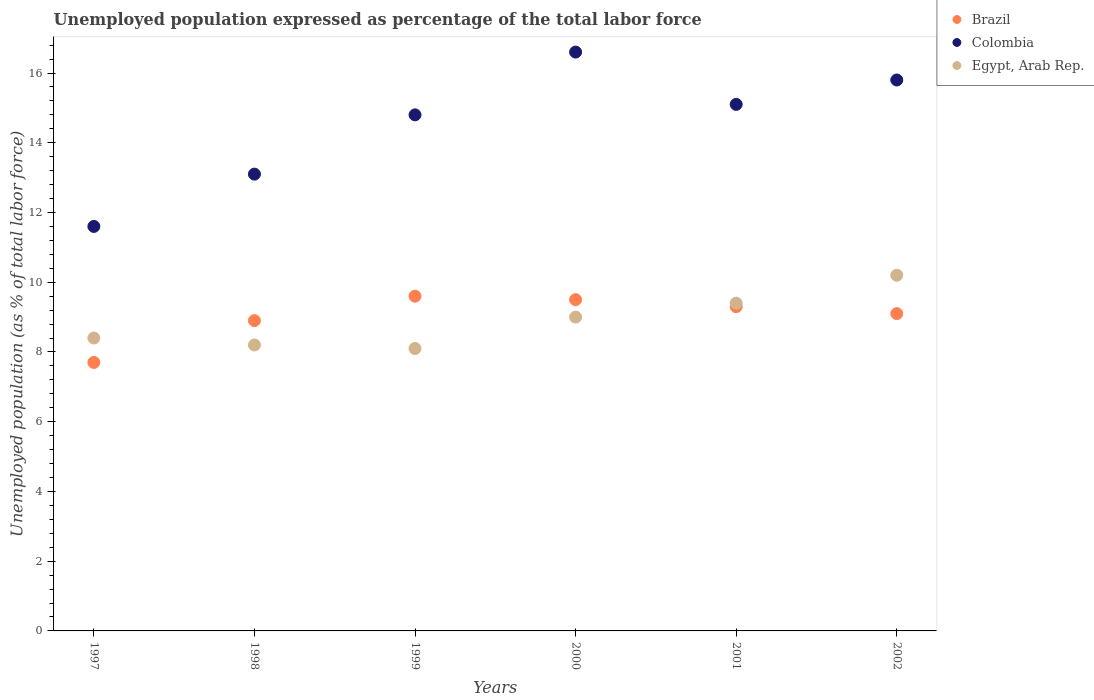How many different coloured dotlines are there?
Provide a succinct answer. 3. What is the unemployment in in Brazil in 1998?
Your answer should be very brief. 8.9. Across all years, what is the maximum unemployment in in Colombia?
Your answer should be compact. 16.6. Across all years, what is the minimum unemployment in in Egypt, Arab Rep.?
Ensure brevity in your answer.  8.1. In which year was the unemployment in in Colombia maximum?
Your answer should be compact. 2000. What is the total unemployment in in Colombia in the graph?
Give a very brief answer. 87. What is the difference between the unemployment in in Brazil in 1997 and that in 2002?
Give a very brief answer. -1.4. What is the difference between the unemployment in in Egypt, Arab Rep. in 1998 and the unemployment in in Colombia in 1999?
Your response must be concise. -6.6. What is the average unemployment in in Colombia per year?
Offer a terse response. 14.5. In the year 2000, what is the difference between the unemployment in in Colombia and unemployment in in Egypt, Arab Rep.?
Give a very brief answer. 7.6. In how many years, is the unemployment in in Egypt, Arab Rep. greater than 9.6 %?
Your answer should be compact. 1. What is the ratio of the unemployment in in Colombia in 1998 to that in 2002?
Ensure brevity in your answer.  0.83. Is the unemployment in in Colombia in 1997 less than that in 1998?
Your answer should be compact. Yes. What is the difference between the highest and the second highest unemployment in in Colombia?
Provide a succinct answer. 0.8. What is the difference between the highest and the lowest unemployment in in Colombia?
Give a very brief answer. 5. Is the sum of the unemployment in in Colombia in 1998 and 1999 greater than the maximum unemployment in in Brazil across all years?
Offer a terse response. Yes. Is it the case that in every year, the sum of the unemployment in in Brazil and unemployment in in Colombia  is greater than the unemployment in in Egypt, Arab Rep.?
Keep it short and to the point. Yes. Does the unemployment in in Egypt, Arab Rep. monotonically increase over the years?
Ensure brevity in your answer.  No. Is the unemployment in in Egypt, Arab Rep. strictly greater than the unemployment in in Brazil over the years?
Make the answer very short. No. How many dotlines are there?
Make the answer very short. 3. How many years are there in the graph?
Give a very brief answer. 6. What is the difference between two consecutive major ticks on the Y-axis?
Provide a succinct answer. 2. Are the values on the major ticks of Y-axis written in scientific E-notation?
Provide a succinct answer. No. Does the graph contain any zero values?
Your response must be concise. No. Does the graph contain grids?
Your answer should be very brief. No. How are the legend labels stacked?
Make the answer very short. Vertical. What is the title of the graph?
Give a very brief answer. Unemployed population expressed as percentage of the total labor force. Does "Faeroe Islands" appear as one of the legend labels in the graph?
Provide a short and direct response. No. What is the label or title of the Y-axis?
Your response must be concise. Unemployed population (as % of total labor force). What is the Unemployed population (as % of total labor force) in Brazil in 1997?
Your answer should be very brief. 7.7. What is the Unemployed population (as % of total labor force) of Colombia in 1997?
Provide a succinct answer. 11.6. What is the Unemployed population (as % of total labor force) in Egypt, Arab Rep. in 1997?
Provide a short and direct response. 8.4. What is the Unemployed population (as % of total labor force) of Brazil in 1998?
Your answer should be very brief. 8.9. What is the Unemployed population (as % of total labor force) in Colombia in 1998?
Make the answer very short. 13.1. What is the Unemployed population (as % of total labor force) of Egypt, Arab Rep. in 1998?
Your answer should be very brief. 8.2. What is the Unemployed population (as % of total labor force) in Brazil in 1999?
Provide a short and direct response. 9.6. What is the Unemployed population (as % of total labor force) in Colombia in 1999?
Your answer should be compact. 14.8. What is the Unemployed population (as % of total labor force) in Egypt, Arab Rep. in 1999?
Your answer should be compact. 8.1. What is the Unemployed population (as % of total labor force) of Brazil in 2000?
Offer a very short reply. 9.5. What is the Unemployed population (as % of total labor force) in Colombia in 2000?
Provide a succinct answer. 16.6. What is the Unemployed population (as % of total labor force) of Brazil in 2001?
Give a very brief answer. 9.3. What is the Unemployed population (as % of total labor force) in Colombia in 2001?
Ensure brevity in your answer.  15.1. What is the Unemployed population (as % of total labor force) of Egypt, Arab Rep. in 2001?
Your answer should be very brief. 9.4. What is the Unemployed population (as % of total labor force) of Brazil in 2002?
Your answer should be very brief. 9.1. What is the Unemployed population (as % of total labor force) in Colombia in 2002?
Offer a terse response. 15.8. What is the Unemployed population (as % of total labor force) of Egypt, Arab Rep. in 2002?
Offer a terse response. 10.2. Across all years, what is the maximum Unemployed population (as % of total labor force) of Brazil?
Ensure brevity in your answer.  9.6. Across all years, what is the maximum Unemployed population (as % of total labor force) of Colombia?
Your response must be concise. 16.6. Across all years, what is the maximum Unemployed population (as % of total labor force) in Egypt, Arab Rep.?
Give a very brief answer. 10.2. Across all years, what is the minimum Unemployed population (as % of total labor force) in Brazil?
Your answer should be very brief. 7.7. Across all years, what is the minimum Unemployed population (as % of total labor force) of Colombia?
Keep it short and to the point. 11.6. Across all years, what is the minimum Unemployed population (as % of total labor force) in Egypt, Arab Rep.?
Make the answer very short. 8.1. What is the total Unemployed population (as % of total labor force) in Brazil in the graph?
Ensure brevity in your answer.  54.1. What is the total Unemployed population (as % of total labor force) in Egypt, Arab Rep. in the graph?
Your response must be concise. 53.3. What is the difference between the Unemployed population (as % of total labor force) in Brazil in 1997 and that in 1998?
Your response must be concise. -1.2. What is the difference between the Unemployed population (as % of total labor force) of Colombia in 1997 and that in 1998?
Provide a short and direct response. -1.5. What is the difference between the Unemployed population (as % of total labor force) in Egypt, Arab Rep. in 1997 and that in 1998?
Provide a succinct answer. 0.2. What is the difference between the Unemployed population (as % of total labor force) of Brazil in 1997 and that in 1999?
Offer a terse response. -1.9. What is the difference between the Unemployed population (as % of total labor force) of Colombia in 1997 and that in 2001?
Your answer should be very brief. -3.5. What is the difference between the Unemployed population (as % of total labor force) of Brazil in 1997 and that in 2002?
Your answer should be very brief. -1.4. What is the difference between the Unemployed population (as % of total labor force) of Colombia in 1997 and that in 2002?
Provide a succinct answer. -4.2. What is the difference between the Unemployed population (as % of total labor force) of Egypt, Arab Rep. in 1997 and that in 2002?
Keep it short and to the point. -1.8. What is the difference between the Unemployed population (as % of total labor force) of Brazil in 1998 and that in 2000?
Your answer should be very brief. -0.6. What is the difference between the Unemployed population (as % of total labor force) in Colombia in 1998 and that in 2000?
Offer a terse response. -3.5. What is the difference between the Unemployed population (as % of total labor force) of Egypt, Arab Rep. in 1998 and that in 2000?
Your answer should be compact. -0.8. What is the difference between the Unemployed population (as % of total labor force) in Egypt, Arab Rep. in 1999 and that in 2000?
Offer a terse response. -0.9. What is the difference between the Unemployed population (as % of total labor force) of Egypt, Arab Rep. in 1999 and that in 2001?
Give a very brief answer. -1.3. What is the difference between the Unemployed population (as % of total labor force) in Brazil in 1999 and that in 2002?
Your answer should be very brief. 0.5. What is the difference between the Unemployed population (as % of total labor force) in Egypt, Arab Rep. in 1999 and that in 2002?
Your response must be concise. -2.1. What is the difference between the Unemployed population (as % of total labor force) of Brazil in 2000 and that in 2001?
Your response must be concise. 0.2. What is the difference between the Unemployed population (as % of total labor force) in Colombia in 2000 and that in 2001?
Your answer should be compact. 1.5. What is the difference between the Unemployed population (as % of total labor force) in Brazil in 2000 and that in 2002?
Make the answer very short. 0.4. What is the difference between the Unemployed population (as % of total labor force) in Brazil in 1997 and the Unemployed population (as % of total labor force) in Egypt, Arab Rep. in 1998?
Make the answer very short. -0.5. What is the difference between the Unemployed population (as % of total labor force) of Brazil in 1997 and the Unemployed population (as % of total labor force) of Colombia in 1999?
Make the answer very short. -7.1. What is the difference between the Unemployed population (as % of total labor force) in Brazil in 1997 and the Unemployed population (as % of total labor force) in Egypt, Arab Rep. in 1999?
Provide a short and direct response. -0.4. What is the difference between the Unemployed population (as % of total labor force) in Brazil in 1997 and the Unemployed population (as % of total labor force) in Colombia in 2000?
Make the answer very short. -8.9. What is the difference between the Unemployed population (as % of total labor force) of Brazil in 1997 and the Unemployed population (as % of total labor force) of Colombia in 2001?
Provide a short and direct response. -7.4. What is the difference between the Unemployed population (as % of total labor force) in Brazil in 1997 and the Unemployed population (as % of total labor force) in Egypt, Arab Rep. in 2001?
Provide a short and direct response. -1.7. What is the difference between the Unemployed population (as % of total labor force) of Brazil in 1997 and the Unemployed population (as % of total labor force) of Egypt, Arab Rep. in 2002?
Provide a succinct answer. -2.5. What is the difference between the Unemployed population (as % of total labor force) in Brazil in 1998 and the Unemployed population (as % of total labor force) in Egypt, Arab Rep. in 1999?
Your answer should be very brief. 0.8. What is the difference between the Unemployed population (as % of total labor force) of Colombia in 1998 and the Unemployed population (as % of total labor force) of Egypt, Arab Rep. in 1999?
Your response must be concise. 5. What is the difference between the Unemployed population (as % of total labor force) in Brazil in 1998 and the Unemployed population (as % of total labor force) in Egypt, Arab Rep. in 2000?
Your answer should be compact. -0.1. What is the difference between the Unemployed population (as % of total labor force) in Brazil in 1998 and the Unemployed population (as % of total labor force) in Colombia in 2001?
Make the answer very short. -6.2. What is the difference between the Unemployed population (as % of total labor force) in Colombia in 1998 and the Unemployed population (as % of total labor force) in Egypt, Arab Rep. in 2001?
Offer a very short reply. 3.7. What is the difference between the Unemployed population (as % of total labor force) of Colombia in 1998 and the Unemployed population (as % of total labor force) of Egypt, Arab Rep. in 2002?
Provide a succinct answer. 2.9. What is the difference between the Unemployed population (as % of total labor force) of Colombia in 1999 and the Unemployed population (as % of total labor force) of Egypt, Arab Rep. in 2000?
Offer a terse response. 5.8. What is the difference between the Unemployed population (as % of total labor force) in Brazil in 1999 and the Unemployed population (as % of total labor force) in Colombia in 2001?
Ensure brevity in your answer.  -5.5. What is the difference between the Unemployed population (as % of total labor force) in Brazil in 1999 and the Unemployed population (as % of total labor force) in Egypt, Arab Rep. in 2001?
Make the answer very short. 0.2. What is the difference between the Unemployed population (as % of total labor force) in Brazil in 1999 and the Unemployed population (as % of total labor force) in Colombia in 2002?
Your answer should be compact. -6.2. What is the difference between the Unemployed population (as % of total labor force) of Brazil in 1999 and the Unemployed population (as % of total labor force) of Egypt, Arab Rep. in 2002?
Offer a terse response. -0.6. What is the difference between the Unemployed population (as % of total labor force) in Brazil in 2000 and the Unemployed population (as % of total labor force) in Egypt, Arab Rep. in 2001?
Your answer should be very brief. 0.1. What is the difference between the Unemployed population (as % of total labor force) of Colombia in 2000 and the Unemployed population (as % of total labor force) of Egypt, Arab Rep. in 2001?
Keep it short and to the point. 7.2. What is the difference between the Unemployed population (as % of total labor force) in Brazil in 2000 and the Unemployed population (as % of total labor force) in Colombia in 2002?
Provide a short and direct response. -6.3. What is the difference between the Unemployed population (as % of total labor force) of Brazil in 2001 and the Unemployed population (as % of total labor force) of Egypt, Arab Rep. in 2002?
Offer a very short reply. -0.9. What is the average Unemployed population (as % of total labor force) of Brazil per year?
Provide a short and direct response. 9.02. What is the average Unemployed population (as % of total labor force) in Colombia per year?
Offer a very short reply. 14.5. What is the average Unemployed population (as % of total labor force) of Egypt, Arab Rep. per year?
Offer a terse response. 8.88. In the year 1997, what is the difference between the Unemployed population (as % of total labor force) in Brazil and Unemployed population (as % of total labor force) in Egypt, Arab Rep.?
Ensure brevity in your answer.  -0.7. In the year 1998, what is the difference between the Unemployed population (as % of total labor force) in Brazil and Unemployed population (as % of total labor force) in Egypt, Arab Rep.?
Offer a very short reply. 0.7. In the year 1999, what is the difference between the Unemployed population (as % of total labor force) of Brazil and Unemployed population (as % of total labor force) of Colombia?
Offer a very short reply. -5.2. In the year 2000, what is the difference between the Unemployed population (as % of total labor force) of Brazil and Unemployed population (as % of total labor force) of Egypt, Arab Rep.?
Offer a very short reply. 0.5. In the year 2000, what is the difference between the Unemployed population (as % of total labor force) of Colombia and Unemployed population (as % of total labor force) of Egypt, Arab Rep.?
Keep it short and to the point. 7.6. In the year 2001, what is the difference between the Unemployed population (as % of total labor force) of Brazil and Unemployed population (as % of total labor force) of Colombia?
Provide a succinct answer. -5.8. In the year 2001, what is the difference between the Unemployed population (as % of total labor force) of Brazil and Unemployed population (as % of total labor force) of Egypt, Arab Rep.?
Offer a terse response. -0.1. In the year 2001, what is the difference between the Unemployed population (as % of total labor force) of Colombia and Unemployed population (as % of total labor force) of Egypt, Arab Rep.?
Offer a very short reply. 5.7. In the year 2002, what is the difference between the Unemployed population (as % of total labor force) of Colombia and Unemployed population (as % of total labor force) of Egypt, Arab Rep.?
Offer a very short reply. 5.6. What is the ratio of the Unemployed population (as % of total labor force) of Brazil in 1997 to that in 1998?
Offer a very short reply. 0.87. What is the ratio of the Unemployed population (as % of total labor force) of Colombia in 1997 to that in 1998?
Provide a short and direct response. 0.89. What is the ratio of the Unemployed population (as % of total labor force) of Egypt, Arab Rep. in 1997 to that in 1998?
Offer a terse response. 1.02. What is the ratio of the Unemployed population (as % of total labor force) in Brazil in 1997 to that in 1999?
Ensure brevity in your answer.  0.8. What is the ratio of the Unemployed population (as % of total labor force) of Colombia in 1997 to that in 1999?
Give a very brief answer. 0.78. What is the ratio of the Unemployed population (as % of total labor force) of Egypt, Arab Rep. in 1997 to that in 1999?
Keep it short and to the point. 1.04. What is the ratio of the Unemployed population (as % of total labor force) in Brazil in 1997 to that in 2000?
Your answer should be very brief. 0.81. What is the ratio of the Unemployed population (as % of total labor force) in Colombia in 1997 to that in 2000?
Offer a very short reply. 0.7. What is the ratio of the Unemployed population (as % of total labor force) of Brazil in 1997 to that in 2001?
Your answer should be very brief. 0.83. What is the ratio of the Unemployed population (as % of total labor force) of Colombia in 1997 to that in 2001?
Offer a terse response. 0.77. What is the ratio of the Unemployed population (as % of total labor force) in Egypt, Arab Rep. in 1997 to that in 2001?
Your answer should be very brief. 0.89. What is the ratio of the Unemployed population (as % of total labor force) in Brazil in 1997 to that in 2002?
Give a very brief answer. 0.85. What is the ratio of the Unemployed population (as % of total labor force) of Colombia in 1997 to that in 2002?
Offer a very short reply. 0.73. What is the ratio of the Unemployed population (as % of total labor force) in Egypt, Arab Rep. in 1997 to that in 2002?
Provide a succinct answer. 0.82. What is the ratio of the Unemployed population (as % of total labor force) of Brazil in 1998 to that in 1999?
Ensure brevity in your answer.  0.93. What is the ratio of the Unemployed population (as % of total labor force) of Colombia in 1998 to that in 1999?
Provide a succinct answer. 0.89. What is the ratio of the Unemployed population (as % of total labor force) in Egypt, Arab Rep. in 1998 to that in 1999?
Your answer should be very brief. 1.01. What is the ratio of the Unemployed population (as % of total labor force) in Brazil in 1998 to that in 2000?
Your answer should be very brief. 0.94. What is the ratio of the Unemployed population (as % of total labor force) in Colombia in 1998 to that in 2000?
Your response must be concise. 0.79. What is the ratio of the Unemployed population (as % of total labor force) in Egypt, Arab Rep. in 1998 to that in 2000?
Your response must be concise. 0.91. What is the ratio of the Unemployed population (as % of total labor force) in Brazil in 1998 to that in 2001?
Keep it short and to the point. 0.96. What is the ratio of the Unemployed population (as % of total labor force) in Colombia in 1998 to that in 2001?
Your response must be concise. 0.87. What is the ratio of the Unemployed population (as % of total labor force) of Egypt, Arab Rep. in 1998 to that in 2001?
Provide a succinct answer. 0.87. What is the ratio of the Unemployed population (as % of total labor force) of Colombia in 1998 to that in 2002?
Provide a succinct answer. 0.83. What is the ratio of the Unemployed population (as % of total labor force) in Egypt, Arab Rep. in 1998 to that in 2002?
Your response must be concise. 0.8. What is the ratio of the Unemployed population (as % of total labor force) in Brazil in 1999 to that in 2000?
Keep it short and to the point. 1.01. What is the ratio of the Unemployed population (as % of total labor force) in Colombia in 1999 to that in 2000?
Give a very brief answer. 0.89. What is the ratio of the Unemployed population (as % of total labor force) of Egypt, Arab Rep. in 1999 to that in 2000?
Ensure brevity in your answer.  0.9. What is the ratio of the Unemployed population (as % of total labor force) of Brazil in 1999 to that in 2001?
Provide a short and direct response. 1.03. What is the ratio of the Unemployed population (as % of total labor force) of Colombia in 1999 to that in 2001?
Your response must be concise. 0.98. What is the ratio of the Unemployed population (as % of total labor force) of Egypt, Arab Rep. in 1999 to that in 2001?
Your answer should be very brief. 0.86. What is the ratio of the Unemployed population (as % of total labor force) of Brazil in 1999 to that in 2002?
Give a very brief answer. 1.05. What is the ratio of the Unemployed population (as % of total labor force) of Colombia in 1999 to that in 2002?
Your answer should be very brief. 0.94. What is the ratio of the Unemployed population (as % of total labor force) in Egypt, Arab Rep. in 1999 to that in 2002?
Make the answer very short. 0.79. What is the ratio of the Unemployed population (as % of total labor force) of Brazil in 2000 to that in 2001?
Your response must be concise. 1.02. What is the ratio of the Unemployed population (as % of total labor force) of Colombia in 2000 to that in 2001?
Provide a short and direct response. 1.1. What is the ratio of the Unemployed population (as % of total labor force) in Egypt, Arab Rep. in 2000 to that in 2001?
Offer a very short reply. 0.96. What is the ratio of the Unemployed population (as % of total labor force) in Brazil in 2000 to that in 2002?
Make the answer very short. 1.04. What is the ratio of the Unemployed population (as % of total labor force) of Colombia in 2000 to that in 2002?
Keep it short and to the point. 1.05. What is the ratio of the Unemployed population (as % of total labor force) of Egypt, Arab Rep. in 2000 to that in 2002?
Ensure brevity in your answer.  0.88. What is the ratio of the Unemployed population (as % of total labor force) in Colombia in 2001 to that in 2002?
Your response must be concise. 0.96. What is the ratio of the Unemployed population (as % of total labor force) of Egypt, Arab Rep. in 2001 to that in 2002?
Offer a terse response. 0.92. What is the difference between the highest and the lowest Unemployed population (as % of total labor force) in Brazil?
Provide a succinct answer. 1.9. 